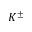<formula> <loc_0><loc_0><loc_500><loc_500>K ^ { \pm }</formula> 